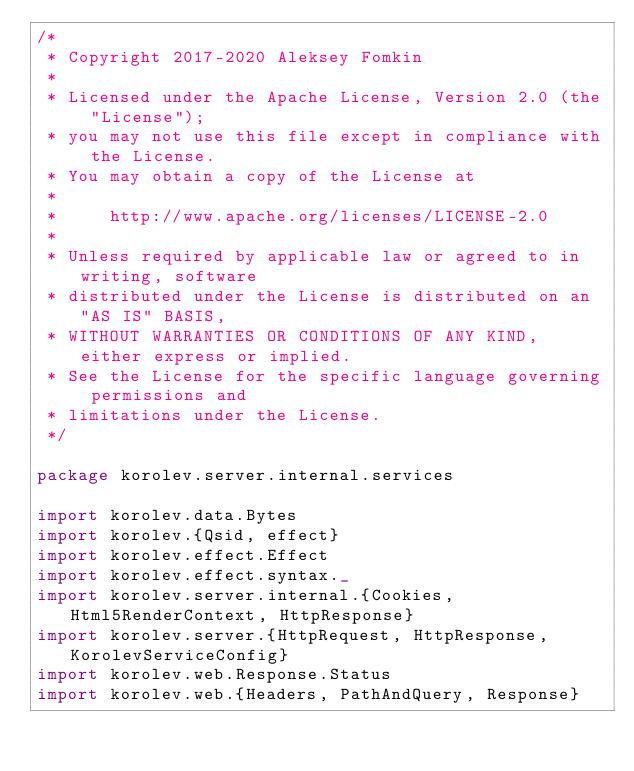<code> <loc_0><loc_0><loc_500><loc_500><_Scala_>/*
 * Copyright 2017-2020 Aleksey Fomkin
 *
 * Licensed under the Apache License, Version 2.0 (the "License");
 * you may not use this file except in compliance with the License.
 * You may obtain a copy of the License at
 *
 *     http://www.apache.org/licenses/LICENSE-2.0
 *
 * Unless required by applicable law or agreed to in writing, software
 * distributed under the License is distributed on an "AS IS" BASIS,
 * WITHOUT WARRANTIES OR CONDITIONS OF ANY KIND, either express or implied.
 * See the License for the specific language governing permissions and
 * limitations under the License.
 */

package korolev.server.internal.services

import korolev.data.Bytes
import korolev.{Qsid, effect}
import korolev.effect.Effect
import korolev.effect.syntax._
import korolev.server.internal.{Cookies, Html5RenderContext, HttpResponse}
import korolev.server.{HttpRequest, HttpResponse, KorolevServiceConfig}
import korolev.web.Response.Status
import korolev.web.{Headers, PathAndQuery, Response}
</code> 